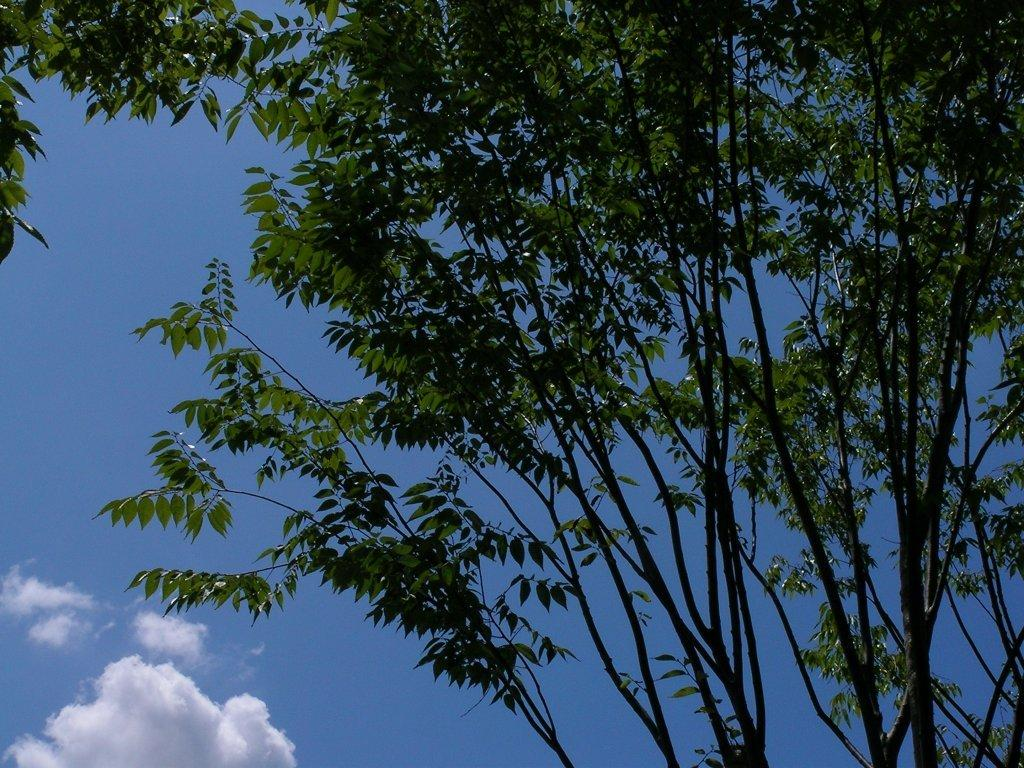What type of vegetation can be seen in the image? There are branches of a tree in the image. What is visible in the background of the image? The sky is visible in the image. How would you describe the sky in the image? The sky appears to be cloudy. How many apples are hanging from the branches in the image? There are no apples visible in the image; only tree branches are present. Is there a lock on the tree branches in the image? There is no lock present on the tree branches in the image. 